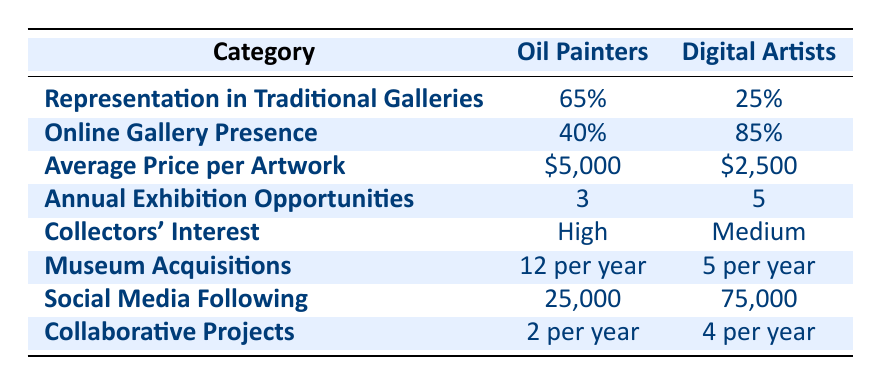What percentage of oil painters are represented in traditional galleries? The table shows that the representation of oil painters in traditional galleries is 65%.
Answer: 65% What is the average price per artwork for digital artists? According to the table, the average price per artwork for digital artists is $2,500.
Answer: $2,500 How many more annual exhibition opportunities do digital artists have compared to oil painters? Digital artists have 5 annual exhibition opportunities while oil painters have 3. The difference is 5 - 3 = 2.
Answer: 2 Is the collectors' interest higher for oil painters than for digital artists? The table states that the collectors' interest is "High" for oil painters and "Medium" for digital artists, indicating that the interest is higher for oil painters.
Answer: Yes What is the total museum acquisition rate for both oil painters and digital artists combined? For oil painters, the museum acquisition rate is 12 per year, and for digital artists, it is 5 per year. The total is 12 + 5 = 17 per year.
Answer: 17 per year Who has a larger social media following, oil painters or digital artists? The table indicates that digital artists have a social media following of 75,000, while oil painters have 25,000. Therefore, digital artists have a larger following.
Answer: Digital artists What is the ratio of oil painters represented in Saatchi Art to digital artists represented in the same gallery? Saatchi Art represents 1500 oil painters and 2200 digital artists. The ratio is 1500:2200, which simplifies to 15:22.
Answer: 15:22 If you were to compare the average price of artwork between the two genres, by how much is the oil paintings' price higher? The average price for oil paintings is $5,000 and for digital artworks it is $2,500. The difference is $5,000 - $2,500 = $2,500.
Answer: $2,500 What percentage of digital artists have online gallery presence compared to oil painters? The table shows that 85% of digital artists and 40% of oil painters have online gallery presence. The percentage of digital artists is significantly higher.
Answer: Higher 